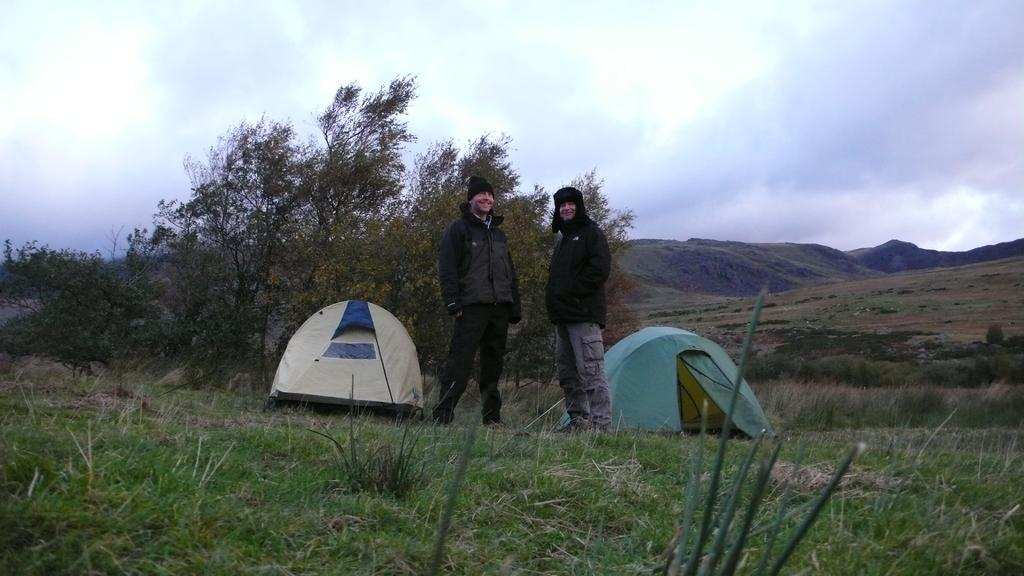How many people are in the image? There are two persons in the image. What is visible beneath the persons' feet? The ground is visible in the image, and grass is present on the ground. What type of vegetation can be seen in the image? Plants and trees are visible in the image. What type of structures are present in the image? Tents are visible in the image. What natural features are visible in the background of the image? Mountains are present in the image. What is visible in the sky in the image? The sky is visible in the image, and clouds are present in the sky. What type of cloth is being used to cover the cabbage in the image? There is no cabbage or cloth present in the image. How many arms does the person on the left have in the image? The image does not show the number of arms the person on the left has; it only shows the person's torso and legs. 